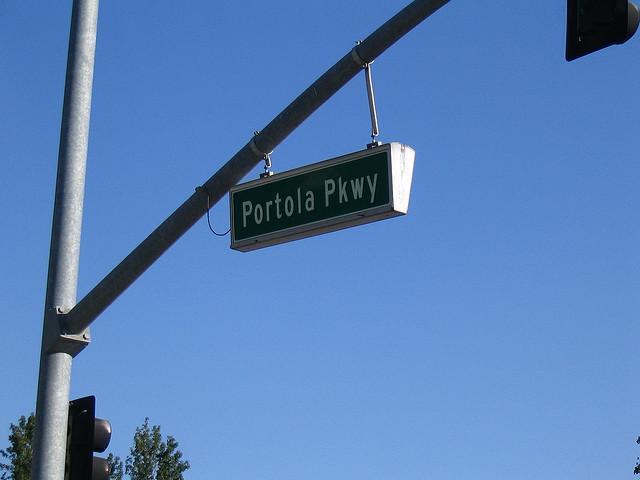How many traffic lights are in the photo?
Give a very brief answer. 2. 